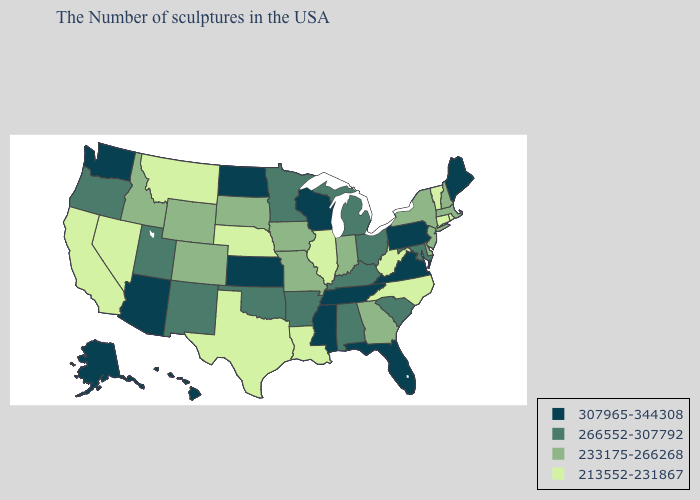Does Iowa have a lower value than South Dakota?
Keep it brief. No. Does Georgia have a lower value than Delaware?
Quick response, please. No. What is the value of Minnesota?
Quick response, please. 266552-307792. Does Iowa have a higher value than South Carolina?
Keep it brief. No. What is the value of Ohio?
Answer briefly. 266552-307792. Does Mississippi have the lowest value in the South?
Give a very brief answer. No. What is the value of Georgia?
Answer briefly. 233175-266268. Name the states that have a value in the range 266552-307792?
Write a very short answer. Maryland, South Carolina, Ohio, Michigan, Kentucky, Alabama, Arkansas, Minnesota, Oklahoma, New Mexico, Utah, Oregon. Does Tennessee have the lowest value in the USA?
Give a very brief answer. No. Among the states that border New Hampshire , which have the lowest value?
Keep it brief. Vermont. What is the highest value in states that border Colorado?
Concise answer only. 307965-344308. Does the first symbol in the legend represent the smallest category?
Write a very short answer. No. Among the states that border Wisconsin , which have the lowest value?
Write a very short answer. Illinois. Does Oregon have the same value as Delaware?
Keep it brief. No. 